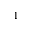Convert formula to latex. <formula><loc_0><loc_0><loc_500><loc_500>1</formula> 